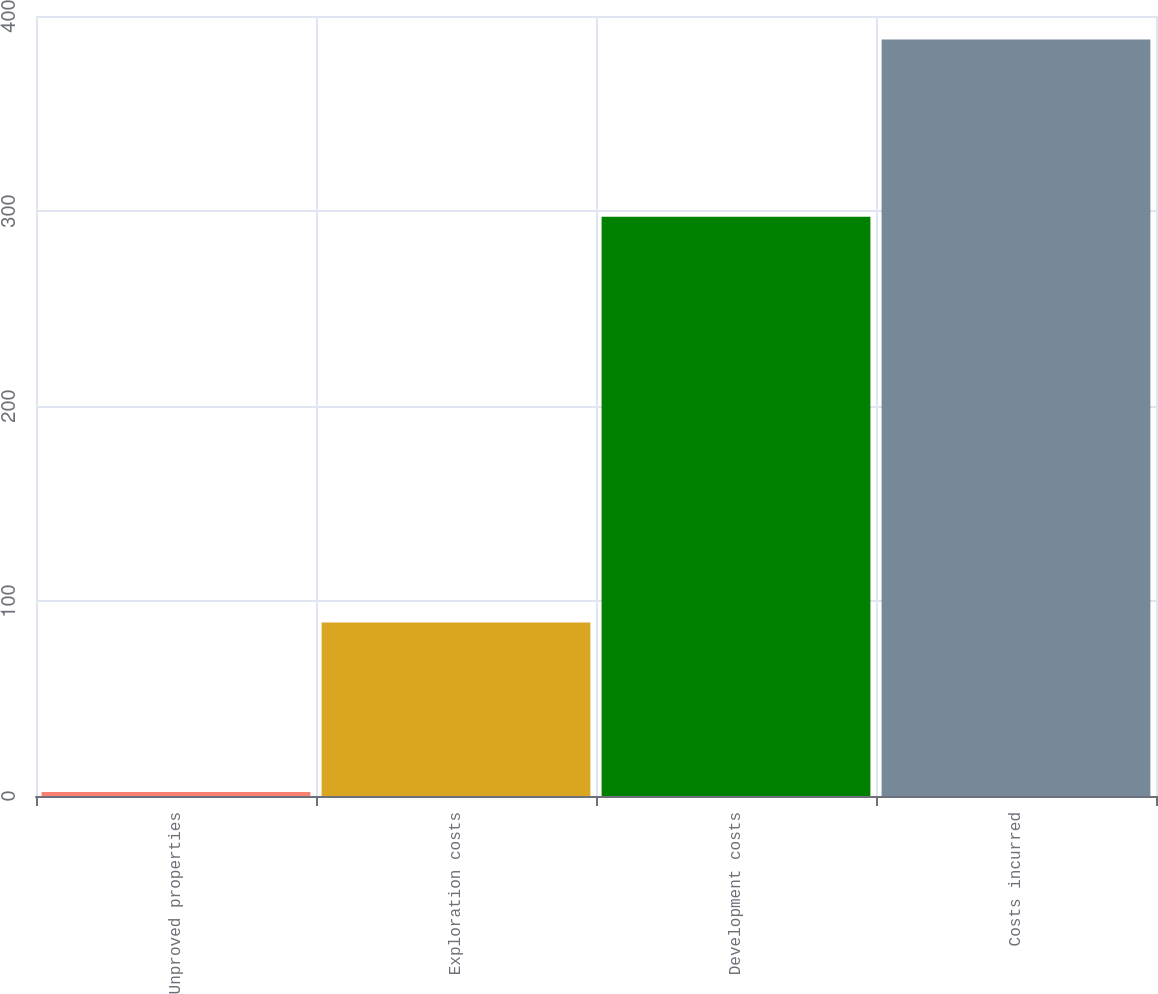Convert chart to OTSL. <chart><loc_0><loc_0><loc_500><loc_500><bar_chart><fcel>Unproved properties<fcel>Exploration costs<fcel>Development costs<fcel>Costs incurred<nl><fcel>2<fcel>89<fcel>297<fcel>388<nl></chart> 